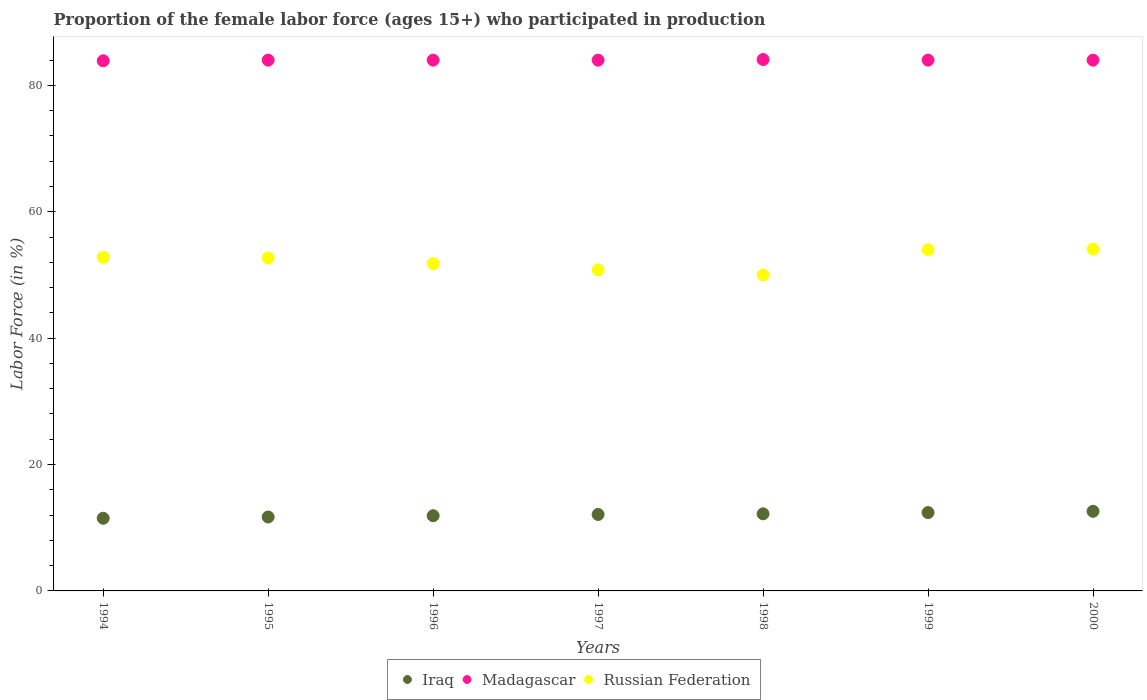How many different coloured dotlines are there?
Offer a terse response. 3. Is the number of dotlines equal to the number of legend labels?
Keep it short and to the point. Yes. What is the proportion of the female labor force who participated in production in Madagascar in 1994?
Your answer should be compact. 83.9. Across all years, what is the maximum proportion of the female labor force who participated in production in Iraq?
Provide a short and direct response. 12.6. In which year was the proportion of the female labor force who participated in production in Madagascar maximum?
Provide a succinct answer. 1998. In which year was the proportion of the female labor force who participated in production in Iraq minimum?
Your answer should be compact. 1994. What is the total proportion of the female labor force who participated in production in Madagascar in the graph?
Keep it short and to the point. 588. What is the difference between the proportion of the female labor force who participated in production in Madagascar in 1998 and the proportion of the female labor force who participated in production in Russian Federation in 1995?
Your response must be concise. 31.4. What is the average proportion of the female labor force who participated in production in Madagascar per year?
Your answer should be compact. 84. In the year 1995, what is the difference between the proportion of the female labor force who participated in production in Iraq and proportion of the female labor force who participated in production in Madagascar?
Offer a very short reply. -72.3. What is the ratio of the proportion of the female labor force who participated in production in Russian Federation in 1994 to that in 1996?
Your answer should be compact. 1.02. What is the difference between the highest and the second highest proportion of the female labor force who participated in production in Iraq?
Give a very brief answer. 0.2. What is the difference between the highest and the lowest proportion of the female labor force who participated in production in Russian Federation?
Offer a very short reply. 4.1. In how many years, is the proportion of the female labor force who participated in production in Iraq greater than the average proportion of the female labor force who participated in production in Iraq taken over all years?
Provide a succinct answer. 4. Is the sum of the proportion of the female labor force who participated in production in Iraq in 1995 and 1997 greater than the maximum proportion of the female labor force who participated in production in Madagascar across all years?
Provide a succinct answer. No. Does the proportion of the female labor force who participated in production in Russian Federation monotonically increase over the years?
Your answer should be very brief. No. Is the proportion of the female labor force who participated in production in Madagascar strictly greater than the proportion of the female labor force who participated in production in Iraq over the years?
Your answer should be very brief. Yes. Is the proportion of the female labor force who participated in production in Madagascar strictly less than the proportion of the female labor force who participated in production in Iraq over the years?
Your answer should be very brief. No. What is the difference between two consecutive major ticks on the Y-axis?
Give a very brief answer. 20. Are the values on the major ticks of Y-axis written in scientific E-notation?
Your answer should be very brief. No. Where does the legend appear in the graph?
Your answer should be compact. Bottom center. How are the legend labels stacked?
Give a very brief answer. Horizontal. What is the title of the graph?
Give a very brief answer. Proportion of the female labor force (ages 15+) who participated in production. Does "Pakistan" appear as one of the legend labels in the graph?
Your response must be concise. No. What is the label or title of the X-axis?
Keep it short and to the point. Years. What is the Labor Force (in %) in Iraq in 1994?
Provide a short and direct response. 11.5. What is the Labor Force (in %) in Madagascar in 1994?
Provide a short and direct response. 83.9. What is the Labor Force (in %) of Russian Federation in 1994?
Keep it short and to the point. 52.8. What is the Labor Force (in %) of Iraq in 1995?
Your response must be concise. 11.7. What is the Labor Force (in %) in Russian Federation in 1995?
Keep it short and to the point. 52.7. What is the Labor Force (in %) of Iraq in 1996?
Your response must be concise. 11.9. What is the Labor Force (in %) of Russian Federation in 1996?
Give a very brief answer. 51.8. What is the Labor Force (in %) in Iraq in 1997?
Provide a short and direct response. 12.1. What is the Labor Force (in %) in Madagascar in 1997?
Provide a succinct answer. 84. What is the Labor Force (in %) of Russian Federation in 1997?
Offer a terse response. 50.8. What is the Labor Force (in %) in Iraq in 1998?
Offer a terse response. 12.2. What is the Labor Force (in %) in Madagascar in 1998?
Your answer should be very brief. 84.1. What is the Labor Force (in %) in Russian Federation in 1998?
Your answer should be compact. 50. What is the Labor Force (in %) of Iraq in 1999?
Provide a short and direct response. 12.4. What is the Labor Force (in %) of Iraq in 2000?
Ensure brevity in your answer.  12.6. What is the Labor Force (in %) in Russian Federation in 2000?
Provide a succinct answer. 54.1. Across all years, what is the maximum Labor Force (in %) in Iraq?
Provide a succinct answer. 12.6. Across all years, what is the maximum Labor Force (in %) in Madagascar?
Make the answer very short. 84.1. Across all years, what is the maximum Labor Force (in %) in Russian Federation?
Make the answer very short. 54.1. Across all years, what is the minimum Labor Force (in %) in Iraq?
Provide a succinct answer. 11.5. Across all years, what is the minimum Labor Force (in %) in Madagascar?
Make the answer very short. 83.9. What is the total Labor Force (in %) in Iraq in the graph?
Provide a short and direct response. 84.4. What is the total Labor Force (in %) in Madagascar in the graph?
Make the answer very short. 588. What is the total Labor Force (in %) in Russian Federation in the graph?
Your answer should be very brief. 366.2. What is the difference between the Labor Force (in %) in Madagascar in 1994 and that in 1995?
Make the answer very short. -0.1. What is the difference between the Labor Force (in %) in Russian Federation in 1994 and that in 1995?
Provide a succinct answer. 0.1. What is the difference between the Labor Force (in %) of Iraq in 1994 and that in 1996?
Offer a very short reply. -0.4. What is the difference between the Labor Force (in %) of Russian Federation in 1994 and that in 1996?
Make the answer very short. 1. What is the difference between the Labor Force (in %) in Russian Federation in 1994 and that in 1997?
Give a very brief answer. 2. What is the difference between the Labor Force (in %) of Russian Federation in 1994 and that in 1998?
Keep it short and to the point. 2.8. What is the difference between the Labor Force (in %) of Iraq in 1994 and that in 1999?
Provide a succinct answer. -0.9. What is the difference between the Labor Force (in %) in Russian Federation in 1994 and that in 1999?
Your answer should be compact. -1.2. What is the difference between the Labor Force (in %) of Russian Federation in 1994 and that in 2000?
Your response must be concise. -1.3. What is the difference between the Labor Force (in %) in Madagascar in 1995 and that in 1996?
Provide a short and direct response. 0. What is the difference between the Labor Force (in %) in Russian Federation in 1995 and that in 1996?
Provide a succinct answer. 0.9. What is the difference between the Labor Force (in %) in Iraq in 1995 and that in 1997?
Offer a terse response. -0.4. What is the difference between the Labor Force (in %) of Iraq in 1995 and that in 1998?
Make the answer very short. -0.5. What is the difference between the Labor Force (in %) in Madagascar in 1995 and that in 1998?
Your answer should be very brief. -0.1. What is the difference between the Labor Force (in %) in Russian Federation in 1995 and that in 1998?
Keep it short and to the point. 2.7. What is the difference between the Labor Force (in %) in Iraq in 1995 and that in 1999?
Your response must be concise. -0.7. What is the difference between the Labor Force (in %) of Madagascar in 1995 and that in 1999?
Offer a terse response. 0. What is the difference between the Labor Force (in %) of Madagascar in 1995 and that in 2000?
Offer a terse response. 0. What is the difference between the Labor Force (in %) in Russian Federation in 1995 and that in 2000?
Keep it short and to the point. -1.4. What is the difference between the Labor Force (in %) in Iraq in 1996 and that in 1997?
Make the answer very short. -0.2. What is the difference between the Labor Force (in %) in Madagascar in 1996 and that in 1997?
Ensure brevity in your answer.  0. What is the difference between the Labor Force (in %) in Russian Federation in 1996 and that in 1997?
Your answer should be compact. 1. What is the difference between the Labor Force (in %) of Iraq in 1996 and that in 1998?
Your response must be concise. -0.3. What is the difference between the Labor Force (in %) of Madagascar in 1996 and that in 1999?
Your answer should be compact. 0. What is the difference between the Labor Force (in %) of Russian Federation in 1996 and that in 1999?
Offer a very short reply. -2.2. What is the difference between the Labor Force (in %) in Iraq in 1996 and that in 2000?
Your answer should be compact. -0.7. What is the difference between the Labor Force (in %) of Russian Federation in 1996 and that in 2000?
Your answer should be very brief. -2.3. What is the difference between the Labor Force (in %) in Russian Federation in 1997 and that in 1998?
Your answer should be very brief. 0.8. What is the difference between the Labor Force (in %) in Russian Federation in 1997 and that in 1999?
Offer a terse response. -3.2. What is the difference between the Labor Force (in %) of Iraq in 1997 and that in 2000?
Ensure brevity in your answer.  -0.5. What is the difference between the Labor Force (in %) in Iraq in 1998 and that in 1999?
Your response must be concise. -0.2. What is the difference between the Labor Force (in %) in Madagascar in 1998 and that in 1999?
Provide a succinct answer. 0.1. What is the difference between the Labor Force (in %) in Madagascar in 1998 and that in 2000?
Provide a short and direct response. 0.1. What is the difference between the Labor Force (in %) in Russian Federation in 1998 and that in 2000?
Your answer should be compact. -4.1. What is the difference between the Labor Force (in %) in Madagascar in 1999 and that in 2000?
Provide a short and direct response. 0. What is the difference between the Labor Force (in %) of Russian Federation in 1999 and that in 2000?
Provide a succinct answer. -0.1. What is the difference between the Labor Force (in %) in Iraq in 1994 and the Labor Force (in %) in Madagascar in 1995?
Give a very brief answer. -72.5. What is the difference between the Labor Force (in %) of Iraq in 1994 and the Labor Force (in %) of Russian Federation in 1995?
Offer a terse response. -41.2. What is the difference between the Labor Force (in %) in Madagascar in 1994 and the Labor Force (in %) in Russian Federation in 1995?
Offer a terse response. 31.2. What is the difference between the Labor Force (in %) in Iraq in 1994 and the Labor Force (in %) in Madagascar in 1996?
Offer a terse response. -72.5. What is the difference between the Labor Force (in %) of Iraq in 1994 and the Labor Force (in %) of Russian Federation in 1996?
Give a very brief answer. -40.3. What is the difference between the Labor Force (in %) in Madagascar in 1994 and the Labor Force (in %) in Russian Federation in 1996?
Ensure brevity in your answer.  32.1. What is the difference between the Labor Force (in %) of Iraq in 1994 and the Labor Force (in %) of Madagascar in 1997?
Provide a short and direct response. -72.5. What is the difference between the Labor Force (in %) of Iraq in 1994 and the Labor Force (in %) of Russian Federation in 1997?
Keep it short and to the point. -39.3. What is the difference between the Labor Force (in %) in Madagascar in 1994 and the Labor Force (in %) in Russian Federation in 1997?
Your response must be concise. 33.1. What is the difference between the Labor Force (in %) of Iraq in 1994 and the Labor Force (in %) of Madagascar in 1998?
Your response must be concise. -72.6. What is the difference between the Labor Force (in %) in Iraq in 1994 and the Labor Force (in %) in Russian Federation in 1998?
Give a very brief answer. -38.5. What is the difference between the Labor Force (in %) in Madagascar in 1994 and the Labor Force (in %) in Russian Federation in 1998?
Offer a very short reply. 33.9. What is the difference between the Labor Force (in %) of Iraq in 1994 and the Labor Force (in %) of Madagascar in 1999?
Your response must be concise. -72.5. What is the difference between the Labor Force (in %) of Iraq in 1994 and the Labor Force (in %) of Russian Federation in 1999?
Give a very brief answer. -42.5. What is the difference between the Labor Force (in %) of Madagascar in 1994 and the Labor Force (in %) of Russian Federation in 1999?
Provide a short and direct response. 29.9. What is the difference between the Labor Force (in %) of Iraq in 1994 and the Labor Force (in %) of Madagascar in 2000?
Make the answer very short. -72.5. What is the difference between the Labor Force (in %) in Iraq in 1994 and the Labor Force (in %) in Russian Federation in 2000?
Offer a terse response. -42.6. What is the difference between the Labor Force (in %) of Madagascar in 1994 and the Labor Force (in %) of Russian Federation in 2000?
Give a very brief answer. 29.8. What is the difference between the Labor Force (in %) in Iraq in 1995 and the Labor Force (in %) in Madagascar in 1996?
Your response must be concise. -72.3. What is the difference between the Labor Force (in %) of Iraq in 1995 and the Labor Force (in %) of Russian Federation in 1996?
Your answer should be compact. -40.1. What is the difference between the Labor Force (in %) of Madagascar in 1995 and the Labor Force (in %) of Russian Federation in 1996?
Offer a terse response. 32.2. What is the difference between the Labor Force (in %) in Iraq in 1995 and the Labor Force (in %) in Madagascar in 1997?
Ensure brevity in your answer.  -72.3. What is the difference between the Labor Force (in %) in Iraq in 1995 and the Labor Force (in %) in Russian Federation in 1997?
Your response must be concise. -39.1. What is the difference between the Labor Force (in %) of Madagascar in 1995 and the Labor Force (in %) of Russian Federation in 1997?
Offer a very short reply. 33.2. What is the difference between the Labor Force (in %) of Iraq in 1995 and the Labor Force (in %) of Madagascar in 1998?
Offer a very short reply. -72.4. What is the difference between the Labor Force (in %) in Iraq in 1995 and the Labor Force (in %) in Russian Federation in 1998?
Your response must be concise. -38.3. What is the difference between the Labor Force (in %) in Madagascar in 1995 and the Labor Force (in %) in Russian Federation in 1998?
Your response must be concise. 34. What is the difference between the Labor Force (in %) of Iraq in 1995 and the Labor Force (in %) of Madagascar in 1999?
Ensure brevity in your answer.  -72.3. What is the difference between the Labor Force (in %) in Iraq in 1995 and the Labor Force (in %) in Russian Federation in 1999?
Offer a terse response. -42.3. What is the difference between the Labor Force (in %) of Madagascar in 1995 and the Labor Force (in %) of Russian Federation in 1999?
Ensure brevity in your answer.  30. What is the difference between the Labor Force (in %) of Iraq in 1995 and the Labor Force (in %) of Madagascar in 2000?
Keep it short and to the point. -72.3. What is the difference between the Labor Force (in %) in Iraq in 1995 and the Labor Force (in %) in Russian Federation in 2000?
Ensure brevity in your answer.  -42.4. What is the difference between the Labor Force (in %) of Madagascar in 1995 and the Labor Force (in %) of Russian Federation in 2000?
Keep it short and to the point. 29.9. What is the difference between the Labor Force (in %) of Iraq in 1996 and the Labor Force (in %) of Madagascar in 1997?
Make the answer very short. -72.1. What is the difference between the Labor Force (in %) of Iraq in 1996 and the Labor Force (in %) of Russian Federation in 1997?
Offer a very short reply. -38.9. What is the difference between the Labor Force (in %) of Madagascar in 1996 and the Labor Force (in %) of Russian Federation in 1997?
Your response must be concise. 33.2. What is the difference between the Labor Force (in %) of Iraq in 1996 and the Labor Force (in %) of Madagascar in 1998?
Provide a short and direct response. -72.2. What is the difference between the Labor Force (in %) of Iraq in 1996 and the Labor Force (in %) of Russian Federation in 1998?
Provide a succinct answer. -38.1. What is the difference between the Labor Force (in %) of Iraq in 1996 and the Labor Force (in %) of Madagascar in 1999?
Provide a succinct answer. -72.1. What is the difference between the Labor Force (in %) in Iraq in 1996 and the Labor Force (in %) in Russian Federation in 1999?
Offer a very short reply. -42.1. What is the difference between the Labor Force (in %) of Madagascar in 1996 and the Labor Force (in %) of Russian Federation in 1999?
Your response must be concise. 30. What is the difference between the Labor Force (in %) in Iraq in 1996 and the Labor Force (in %) in Madagascar in 2000?
Your answer should be very brief. -72.1. What is the difference between the Labor Force (in %) in Iraq in 1996 and the Labor Force (in %) in Russian Federation in 2000?
Your answer should be compact. -42.2. What is the difference between the Labor Force (in %) of Madagascar in 1996 and the Labor Force (in %) of Russian Federation in 2000?
Make the answer very short. 29.9. What is the difference between the Labor Force (in %) in Iraq in 1997 and the Labor Force (in %) in Madagascar in 1998?
Ensure brevity in your answer.  -72. What is the difference between the Labor Force (in %) of Iraq in 1997 and the Labor Force (in %) of Russian Federation in 1998?
Ensure brevity in your answer.  -37.9. What is the difference between the Labor Force (in %) in Madagascar in 1997 and the Labor Force (in %) in Russian Federation in 1998?
Keep it short and to the point. 34. What is the difference between the Labor Force (in %) in Iraq in 1997 and the Labor Force (in %) in Madagascar in 1999?
Your response must be concise. -71.9. What is the difference between the Labor Force (in %) in Iraq in 1997 and the Labor Force (in %) in Russian Federation in 1999?
Your answer should be compact. -41.9. What is the difference between the Labor Force (in %) in Madagascar in 1997 and the Labor Force (in %) in Russian Federation in 1999?
Provide a succinct answer. 30. What is the difference between the Labor Force (in %) of Iraq in 1997 and the Labor Force (in %) of Madagascar in 2000?
Make the answer very short. -71.9. What is the difference between the Labor Force (in %) of Iraq in 1997 and the Labor Force (in %) of Russian Federation in 2000?
Offer a terse response. -42. What is the difference between the Labor Force (in %) in Madagascar in 1997 and the Labor Force (in %) in Russian Federation in 2000?
Your answer should be very brief. 29.9. What is the difference between the Labor Force (in %) in Iraq in 1998 and the Labor Force (in %) in Madagascar in 1999?
Keep it short and to the point. -71.8. What is the difference between the Labor Force (in %) in Iraq in 1998 and the Labor Force (in %) in Russian Federation in 1999?
Provide a short and direct response. -41.8. What is the difference between the Labor Force (in %) of Madagascar in 1998 and the Labor Force (in %) of Russian Federation in 1999?
Provide a succinct answer. 30.1. What is the difference between the Labor Force (in %) in Iraq in 1998 and the Labor Force (in %) in Madagascar in 2000?
Your answer should be very brief. -71.8. What is the difference between the Labor Force (in %) of Iraq in 1998 and the Labor Force (in %) of Russian Federation in 2000?
Your response must be concise. -41.9. What is the difference between the Labor Force (in %) in Madagascar in 1998 and the Labor Force (in %) in Russian Federation in 2000?
Offer a terse response. 30. What is the difference between the Labor Force (in %) of Iraq in 1999 and the Labor Force (in %) of Madagascar in 2000?
Your response must be concise. -71.6. What is the difference between the Labor Force (in %) in Iraq in 1999 and the Labor Force (in %) in Russian Federation in 2000?
Provide a short and direct response. -41.7. What is the difference between the Labor Force (in %) in Madagascar in 1999 and the Labor Force (in %) in Russian Federation in 2000?
Offer a very short reply. 29.9. What is the average Labor Force (in %) of Iraq per year?
Make the answer very short. 12.06. What is the average Labor Force (in %) in Madagascar per year?
Provide a short and direct response. 84. What is the average Labor Force (in %) in Russian Federation per year?
Make the answer very short. 52.31. In the year 1994, what is the difference between the Labor Force (in %) of Iraq and Labor Force (in %) of Madagascar?
Give a very brief answer. -72.4. In the year 1994, what is the difference between the Labor Force (in %) of Iraq and Labor Force (in %) of Russian Federation?
Your response must be concise. -41.3. In the year 1994, what is the difference between the Labor Force (in %) in Madagascar and Labor Force (in %) in Russian Federation?
Offer a terse response. 31.1. In the year 1995, what is the difference between the Labor Force (in %) of Iraq and Labor Force (in %) of Madagascar?
Offer a terse response. -72.3. In the year 1995, what is the difference between the Labor Force (in %) in Iraq and Labor Force (in %) in Russian Federation?
Give a very brief answer. -41. In the year 1995, what is the difference between the Labor Force (in %) in Madagascar and Labor Force (in %) in Russian Federation?
Keep it short and to the point. 31.3. In the year 1996, what is the difference between the Labor Force (in %) of Iraq and Labor Force (in %) of Madagascar?
Your answer should be compact. -72.1. In the year 1996, what is the difference between the Labor Force (in %) of Iraq and Labor Force (in %) of Russian Federation?
Provide a succinct answer. -39.9. In the year 1996, what is the difference between the Labor Force (in %) of Madagascar and Labor Force (in %) of Russian Federation?
Your answer should be compact. 32.2. In the year 1997, what is the difference between the Labor Force (in %) in Iraq and Labor Force (in %) in Madagascar?
Keep it short and to the point. -71.9. In the year 1997, what is the difference between the Labor Force (in %) in Iraq and Labor Force (in %) in Russian Federation?
Give a very brief answer. -38.7. In the year 1997, what is the difference between the Labor Force (in %) in Madagascar and Labor Force (in %) in Russian Federation?
Make the answer very short. 33.2. In the year 1998, what is the difference between the Labor Force (in %) in Iraq and Labor Force (in %) in Madagascar?
Your answer should be very brief. -71.9. In the year 1998, what is the difference between the Labor Force (in %) of Iraq and Labor Force (in %) of Russian Federation?
Offer a very short reply. -37.8. In the year 1998, what is the difference between the Labor Force (in %) in Madagascar and Labor Force (in %) in Russian Federation?
Keep it short and to the point. 34.1. In the year 1999, what is the difference between the Labor Force (in %) of Iraq and Labor Force (in %) of Madagascar?
Keep it short and to the point. -71.6. In the year 1999, what is the difference between the Labor Force (in %) of Iraq and Labor Force (in %) of Russian Federation?
Provide a short and direct response. -41.6. In the year 2000, what is the difference between the Labor Force (in %) of Iraq and Labor Force (in %) of Madagascar?
Make the answer very short. -71.4. In the year 2000, what is the difference between the Labor Force (in %) in Iraq and Labor Force (in %) in Russian Federation?
Offer a terse response. -41.5. In the year 2000, what is the difference between the Labor Force (in %) of Madagascar and Labor Force (in %) of Russian Federation?
Make the answer very short. 29.9. What is the ratio of the Labor Force (in %) of Iraq in 1994 to that in 1995?
Keep it short and to the point. 0.98. What is the ratio of the Labor Force (in %) in Madagascar in 1994 to that in 1995?
Ensure brevity in your answer.  1. What is the ratio of the Labor Force (in %) of Russian Federation in 1994 to that in 1995?
Give a very brief answer. 1. What is the ratio of the Labor Force (in %) in Iraq in 1994 to that in 1996?
Provide a short and direct response. 0.97. What is the ratio of the Labor Force (in %) in Madagascar in 1994 to that in 1996?
Give a very brief answer. 1. What is the ratio of the Labor Force (in %) of Russian Federation in 1994 to that in 1996?
Ensure brevity in your answer.  1.02. What is the ratio of the Labor Force (in %) of Iraq in 1994 to that in 1997?
Your answer should be compact. 0.95. What is the ratio of the Labor Force (in %) of Russian Federation in 1994 to that in 1997?
Make the answer very short. 1.04. What is the ratio of the Labor Force (in %) in Iraq in 1994 to that in 1998?
Your response must be concise. 0.94. What is the ratio of the Labor Force (in %) in Madagascar in 1994 to that in 1998?
Offer a very short reply. 1. What is the ratio of the Labor Force (in %) of Russian Federation in 1994 to that in 1998?
Keep it short and to the point. 1.06. What is the ratio of the Labor Force (in %) of Iraq in 1994 to that in 1999?
Your answer should be compact. 0.93. What is the ratio of the Labor Force (in %) of Madagascar in 1994 to that in 1999?
Ensure brevity in your answer.  1. What is the ratio of the Labor Force (in %) of Russian Federation in 1994 to that in 1999?
Provide a short and direct response. 0.98. What is the ratio of the Labor Force (in %) of Iraq in 1994 to that in 2000?
Ensure brevity in your answer.  0.91. What is the ratio of the Labor Force (in %) in Madagascar in 1994 to that in 2000?
Provide a succinct answer. 1. What is the ratio of the Labor Force (in %) in Russian Federation in 1994 to that in 2000?
Make the answer very short. 0.98. What is the ratio of the Labor Force (in %) of Iraq in 1995 to that in 1996?
Ensure brevity in your answer.  0.98. What is the ratio of the Labor Force (in %) in Madagascar in 1995 to that in 1996?
Give a very brief answer. 1. What is the ratio of the Labor Force (in %) of Russian Federation in 1995 to that in 1996?
Make the answer very short. 1.02. What is the ratio of the Labor Force (in %) of Iraq in 1995 to that in 1997?
Provide a succinct answer. 0.97. What is the ratio of the Labor Force (in %) of Madagascar in 1995 to that in 1997?
Ensure brevity in your answer.  1. What is the ratio of the Labor Force (in %) in Russian Federation in 1995 to that in 1997?
Your response must be concise. 1.04. What is the ratio of the Labor Force (in %) in Madagascar in 1995 to that in 1998?
Offer a terse response. 1. What is the ratio of the Labor Force (in %) of Russian Federation in 1995 to that in 1998?
Offer a terse response. 1.05. What is the ratio of the Labor Force (in %) in Iraq in 1995 to that in 1999?
Your answer should be compact. 0.94. What is the ratio of the Labor Force (in %) of Madagascar in 1995 to that in 1999?
Keep it short and to the point. 1. What is the ratio of the Labor Force (in %) in Russian Federation in 1995 to that in 1999?
Keep it short and to the point. 0.98. What is the ratio of the Labor Force (in %) in Madagascar in 1995 to that in 2000?
Ensure brevity in your answer.  1. What is the ratio of the Labor Force (in %) of Russian Federation in 1995 to that in 2000?
Your answer should be very brief. 0.97. What is the ratio of the Labor Force (in %) in Iraq in 1996 to that in 1997?
Offer a very short reply. 0.98. What is the ratio of the Labor Force (in %) of Madagascar in 1996 to that in 1997?
Provide a short and direct response. 1. What is the ratio of the Labor Force (in %) in Russian Federation in 1996 to that in 1997?
Provide a succinct answer. 1.02. What is the ratio of the Labor Force (in %) in Iraq in 1996 to that in 1998?
Keep it short and to the point. 0.98. What is the ratio of the Labor Force (in %) in Russian Federation in 1996 to that in 1998?
Your answer should be compact. 1.04. What is the ratio of the Labor Force (in %) in Iraq in 1996 to that in 1999?
Offer a terse response. 0.96. What is the ratio of the Labor Force (in %) in Russian Federation in 1996 to that in 1999?
Your answer should be very brief. 0.96. What is the ratio of the Labor Force (in %) of Madagascar in 1996 to that in 2000?
Provide a succinct answer. 1. What is the ratio of the Labor Force (in %) of Russian Federation in 1996 to that in 2000?
Provide a short and direct response. 0.96. What is the ratio of the Labor Force (in %) of Russian Federation in 1997 to that in 1998?
Your answer should be compact. 1.02. What is the ratio of the Labor Force (in %) in Iraq in 1997 to that in 1999?
Keep it short and to the point. 0.98. What is the ratio of the Labor Force (in %) in Russian Federation in 1997 to that in 1999?
Your response must be concise. 0.94. What is the ratio of the Labor Force (in %) in Iraq in 1997 to that in 2000?
Your answer should be very brief. 0.96. What is the ratio of the Labor Force (in %) of Madagascar in 1997 to that in 2000?
Offer a terse response. 1. What is the ratio of the Labor Force (in %) of Russian Federation in 1997 to that in 2000?
Provide a short and direct response. 0.94. What is the ratio of the Labor Force (in %) in Iraq in 1998 to that in 1999?
Offer a very short reply. 0.98. What is the ratio of the Labor Force (in %) in Russian Federation in 1998 to that in 1999?
Make the answer very short. 0.93. What is the ratio of the Labor Force (in %) in Iraq in 1998 to that in 2000?
Provide a short and direct response. 0.97. What is the ratio of the Labor Force (in %) of Russian Federation in 1998 to that in 2000?
Make the answer very short. 0.92. What is the ratio of the Labor Force (in %) in Iraq in 1999 to that in 2000?
Offer a very short reply. 0.98. What is the ratio of the Labor Force (in %) of Madagascar in 1999 to that in 2000?
Provide a succinct answer. 1. What is the difference between the highest and the second highest Labor Force (in %) in Madagascar?
Keep it short and to the point. 0.1. 